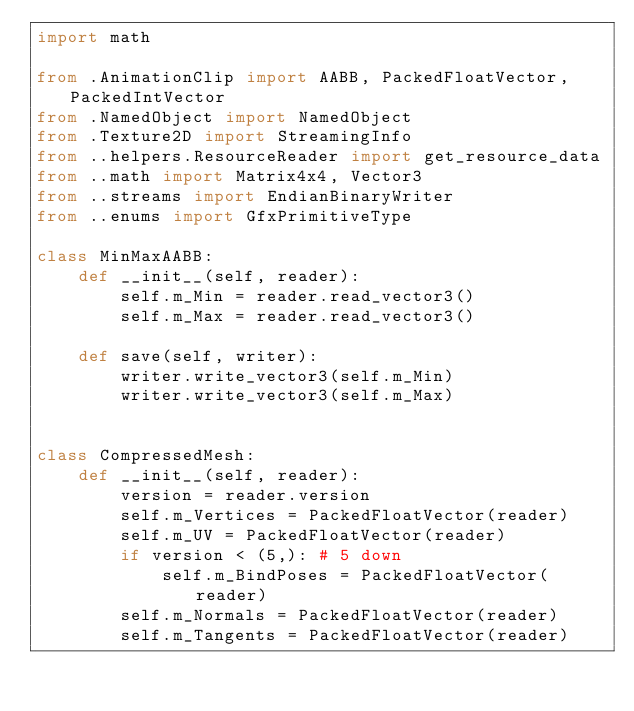<code> <loc_0><loc_0><loc_500><loc_500><_Python_>import math

from .AnimationClip import AABB, PackedFloatVector, PackedIntVector
from .NamedObject import NamedObject
from .Texture2D import StreamingInfo
from ..helpers.ResourceReader import get_resource_data
from ..math import Matrix4x4, Vector3
from ..streams import EndianBinaryWriter
from ..enums import GfxPrimitiveType

class MinMaxAABB:
    def __init__(self, reader):
        self.m_Min = reader.read_vector3()
        self.m_Max = reader.read_vector3()

    def save(self, writer):
        writer.write_vector3(self.m_Min)
        writer.write_vector3(self.m_Max)


class CompressedMesh:
    def __init__(self, reader):
        version = reader.version
        self.m_Vertices = PackedFloatVector(reader)
        self.m_UV = PackedFloatVector(reader)
        if version < (5,): # 5 down
            self.m_BindPoses = PackedFloatVector(reader)
        self.m_Normals = PackedFloatVector(reader)
        self.m_Tangents = PackedFloatVector(reader)</code> 